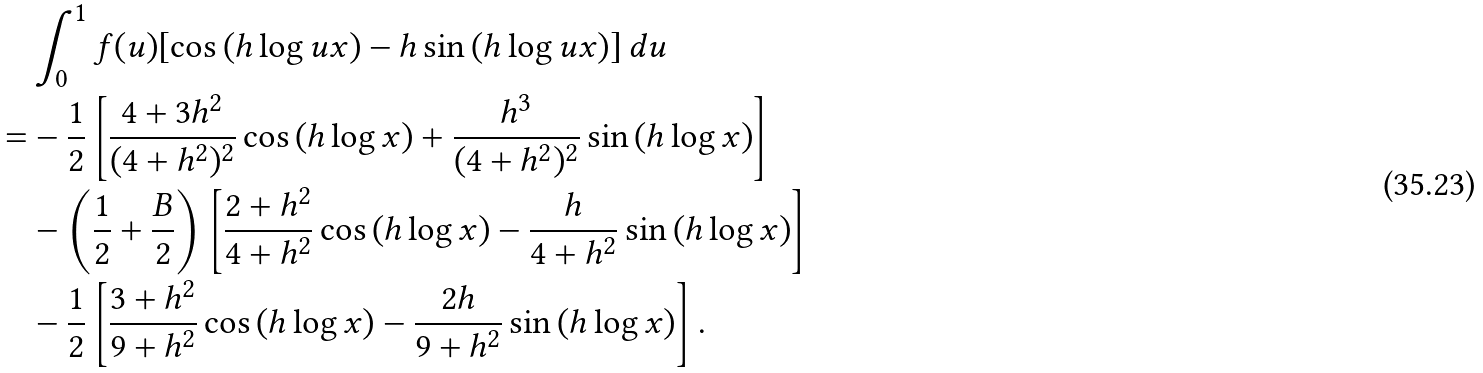<formula> <loc_0><loc_0><loc_500><loc_500>& \int _ { 0 } ^ { 1 } f ( u ) [ \cos { ( h \log { u x } ) } - h \sin { ( h \log { u x } ) } ] \, d u \\ = & - \frac { 1 } { 2 } \left [ \frac { 4 + 3 h ^ { 2 } } { ( 4 + h ^ { 2 } ) ^ { 2 } } \cos { ( h \log { x } ) } + \frac { h ^ { 3 } } { ( 4 + h ^ { 2 } ) ^ { 2 } } \sin { ( h \log { x } ) } \right ] \\ & - \left ( \frac { 1 } { 2 } + \frac { B } { 2 } \right ) \left [ \frac { 2 + h ^ { 2 } } { 4 + h ^ { 2 } } \cos { ( h \log { x } ) } - \frac { h } { 4 + h ^ { 2 } } \sin { ( h \log { x } ) } \right ] \\ & - \frac { 1 } { 2 } \left [ \frac { 3 + h ^ { 2 } } { 9 + h ^ { 2 } } \cos { ( h \log { x } ) } - \frac { 2 h } { 9 + h ^ { 2 } } \sin { ( h \log { x } ) } \right ] .</formula> 